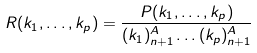<formula> <loc_0><loc_0><loc_500><loc_500>R ( k _ { 1 } , \dots , k _ { p } ) = \frac { P ( k _ { 1 } , \dots , k _ { p } ) } { ( k _ { 1 } ) _ { n + 1 } ^ { A } \dots ( k _ { p } ) _ { n + 1 } ^ { A } }</formula> 